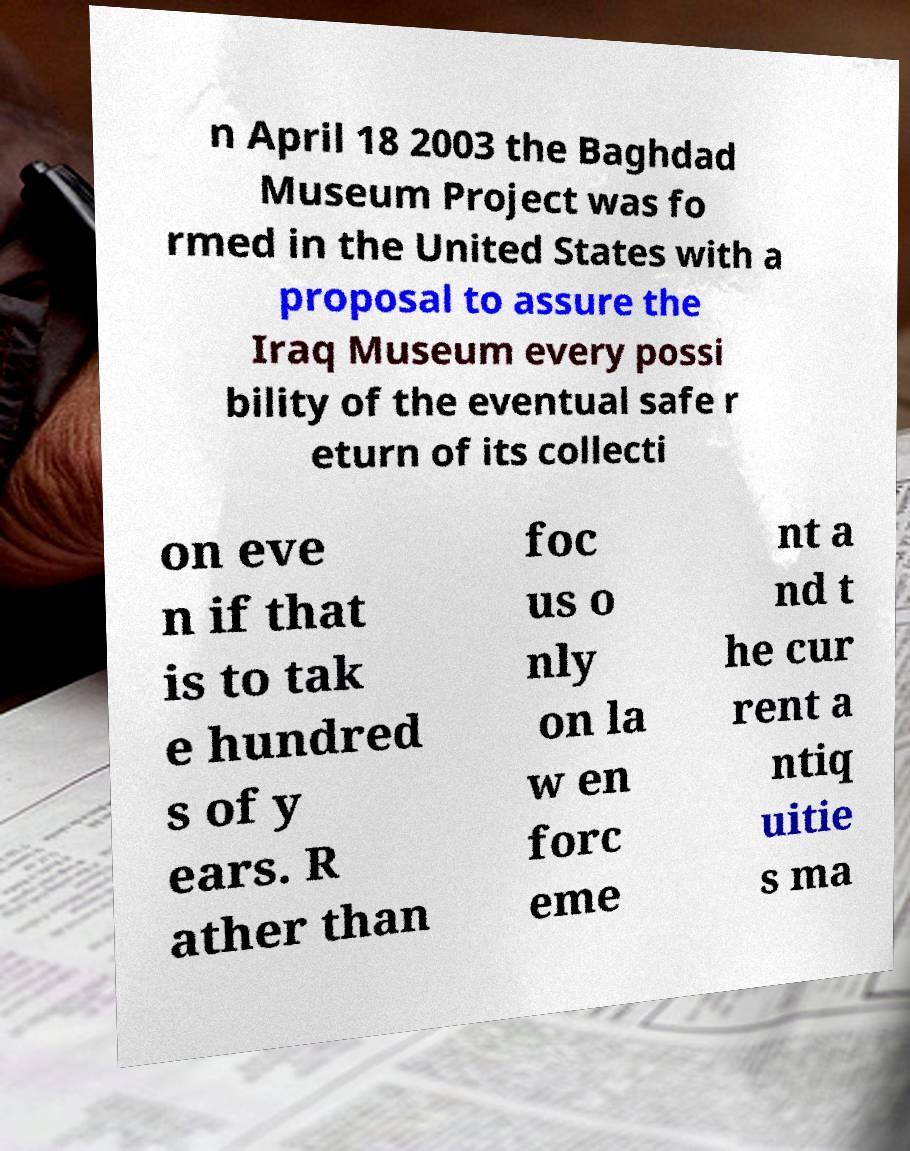I need the written content from this picture converted into text. Can you do that? n April 18 2003 the Baghdad Museum Project was fo rmed in the United States with a proposal to assure the Iraq Museum every possi bility of the eventual safe r eturn of its collecti on eve n if that is to tak e hundred s of y ears. R ather than foc us o nly on la w en forc eme nt a nd t he cur rent a ntiq uitie s ma 